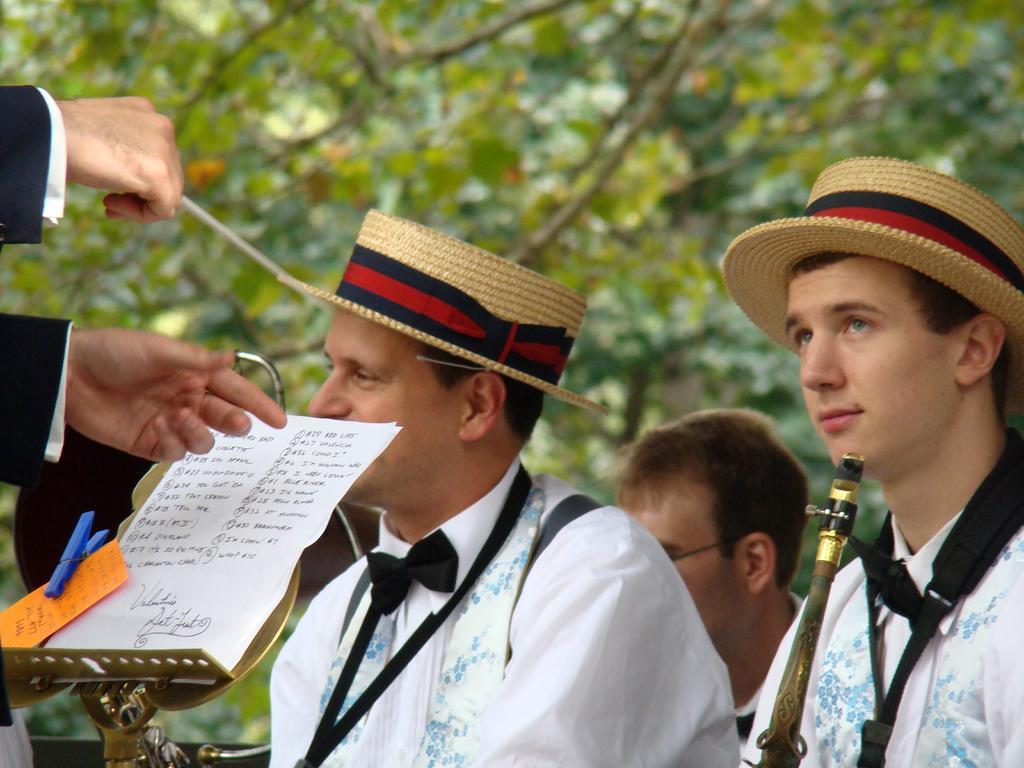Describe this image in one or two sentences. In this image I can see people among them two men are wearing hats and white color clothes. Here I can see papers on an object. I can also see something written on papers. Here I can see a musical instrument. In the background I can see trees. The background of the image is blurred. 